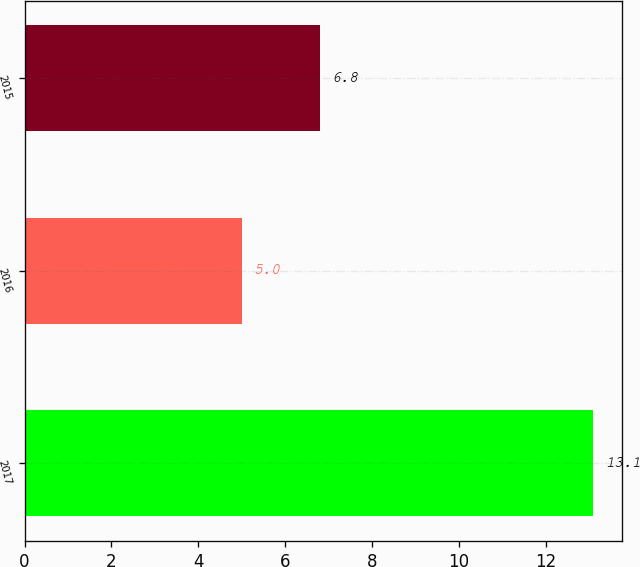<chart> <loc_0><loc_0><loc_500><loc_500><bar_chart><fcel>2017<fcel>2016<fcel>2015<nl><fcel>13.1<fcel>5<fcel>6.8<nl></chart> 